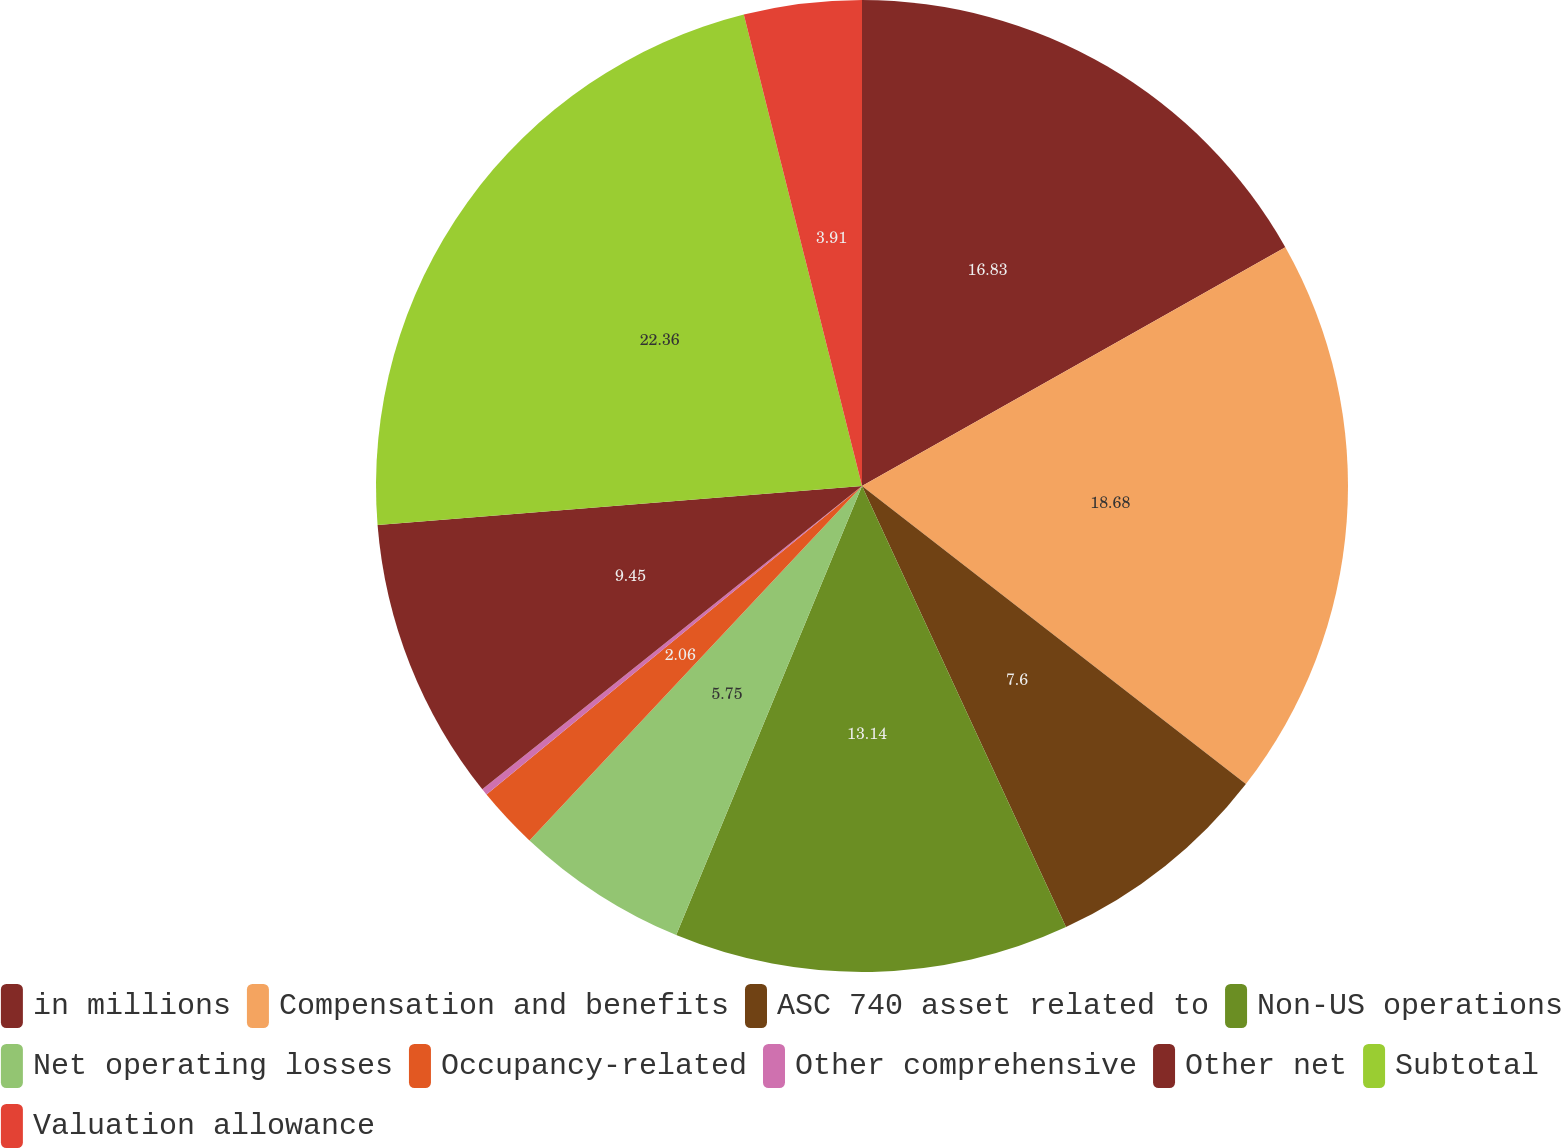<chart> <loc_0><loc_0><loc_500><loc_500><pie_chart><fcel>in millions<fcel>Compensation and benefits<fcel>ASC 740 asset related to<fcel>Non-US operations<fcel>Net operating losses<fcel>Occupancy-related<fcel>Other comprehensive<fcel>Other net<fcel>Subtotal<fcel>Valuation allowance<nl><fcel>16.83%<fcel>18.68%<fcel>7.6%<fcel>13.14%<fcel>5.75%<fcel>2.06%<fcel>0.22%<fcel>9.45%<fcel>22.37%<fcel>3.91%<nl></chart> 